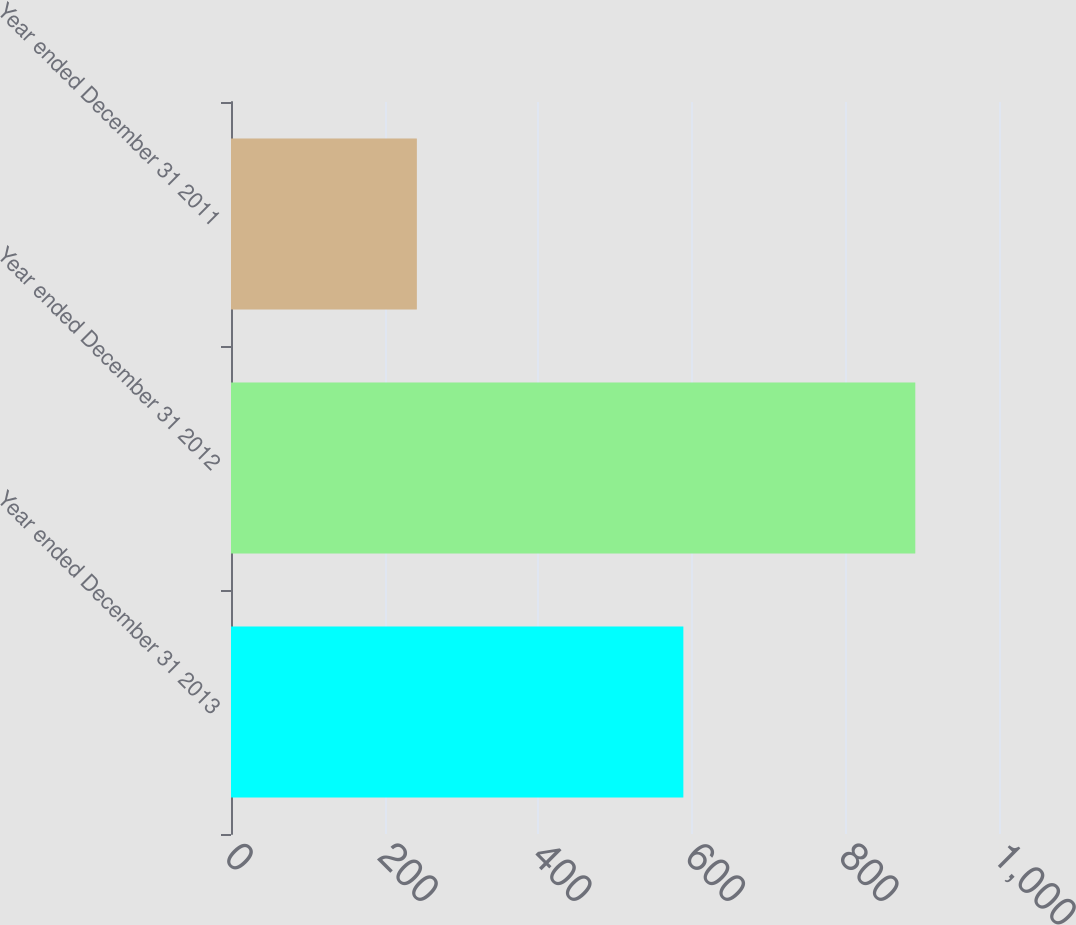<chart> <loc_0><loc_0><loc_500><loc_500><bar_chart><fcel>Year ended December 31 2013<fcel>Year ended December 31 2012<fcel>Year ended December 31 2011<nl><fcel>589<fcel>891<fcel>242<nl></chart> 